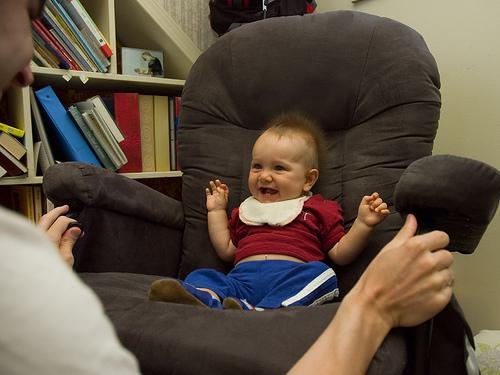Is there a chair in the image? Yes 